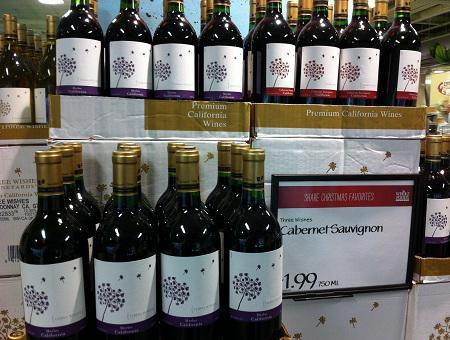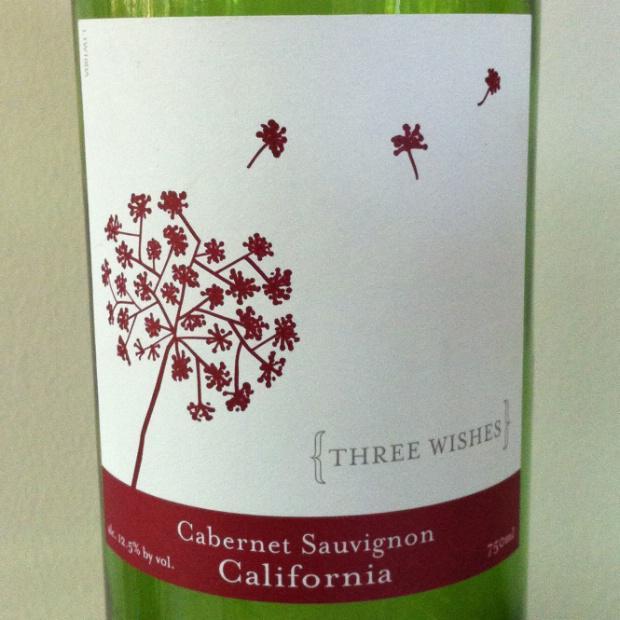The first image is the image on the left, the second image is the image on the right. For the images shown, is this caption "There are exactly three bottles of wine featured in one of the images." true? Answer yes or no. No. 